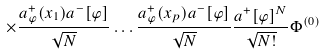Convert formula to latex. <formula><loc_0><loc_0><loc_500><loc_500>\times \frac { a ^ { + } _ { \varphi } ( x _ { 1 } ) a ^ { - } [ \varphi ] } { \sqrt { N } } \dots \frac { a ^ { + } _ { \varphi } ( x _ { p } ) a ^ { - } [ \varphi ] } { \sqrt { N } } \frac { a ^ { + } [ \varphi ] ^ { N } } { \sqrt { N ! } } \Phi ^ { ( 0 ) }</formula> 